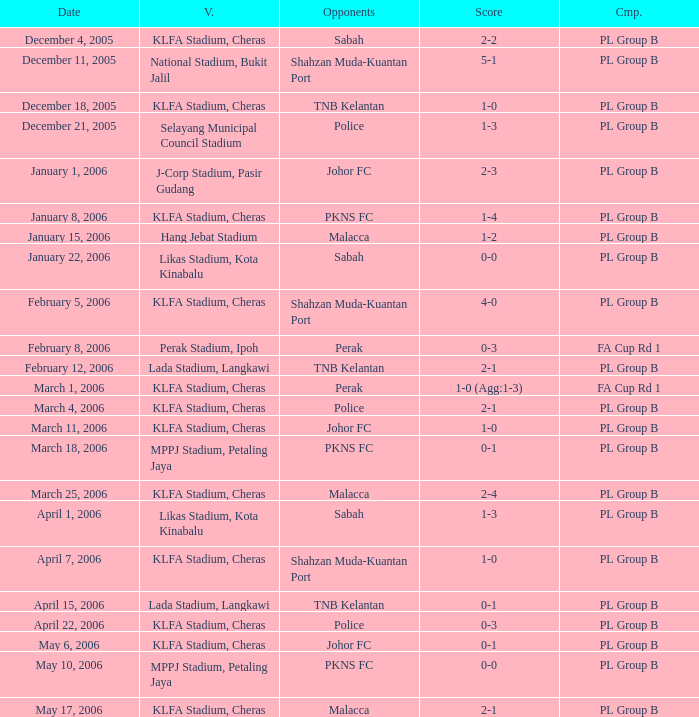Who competed on may 6, 2006? Johor FC. 